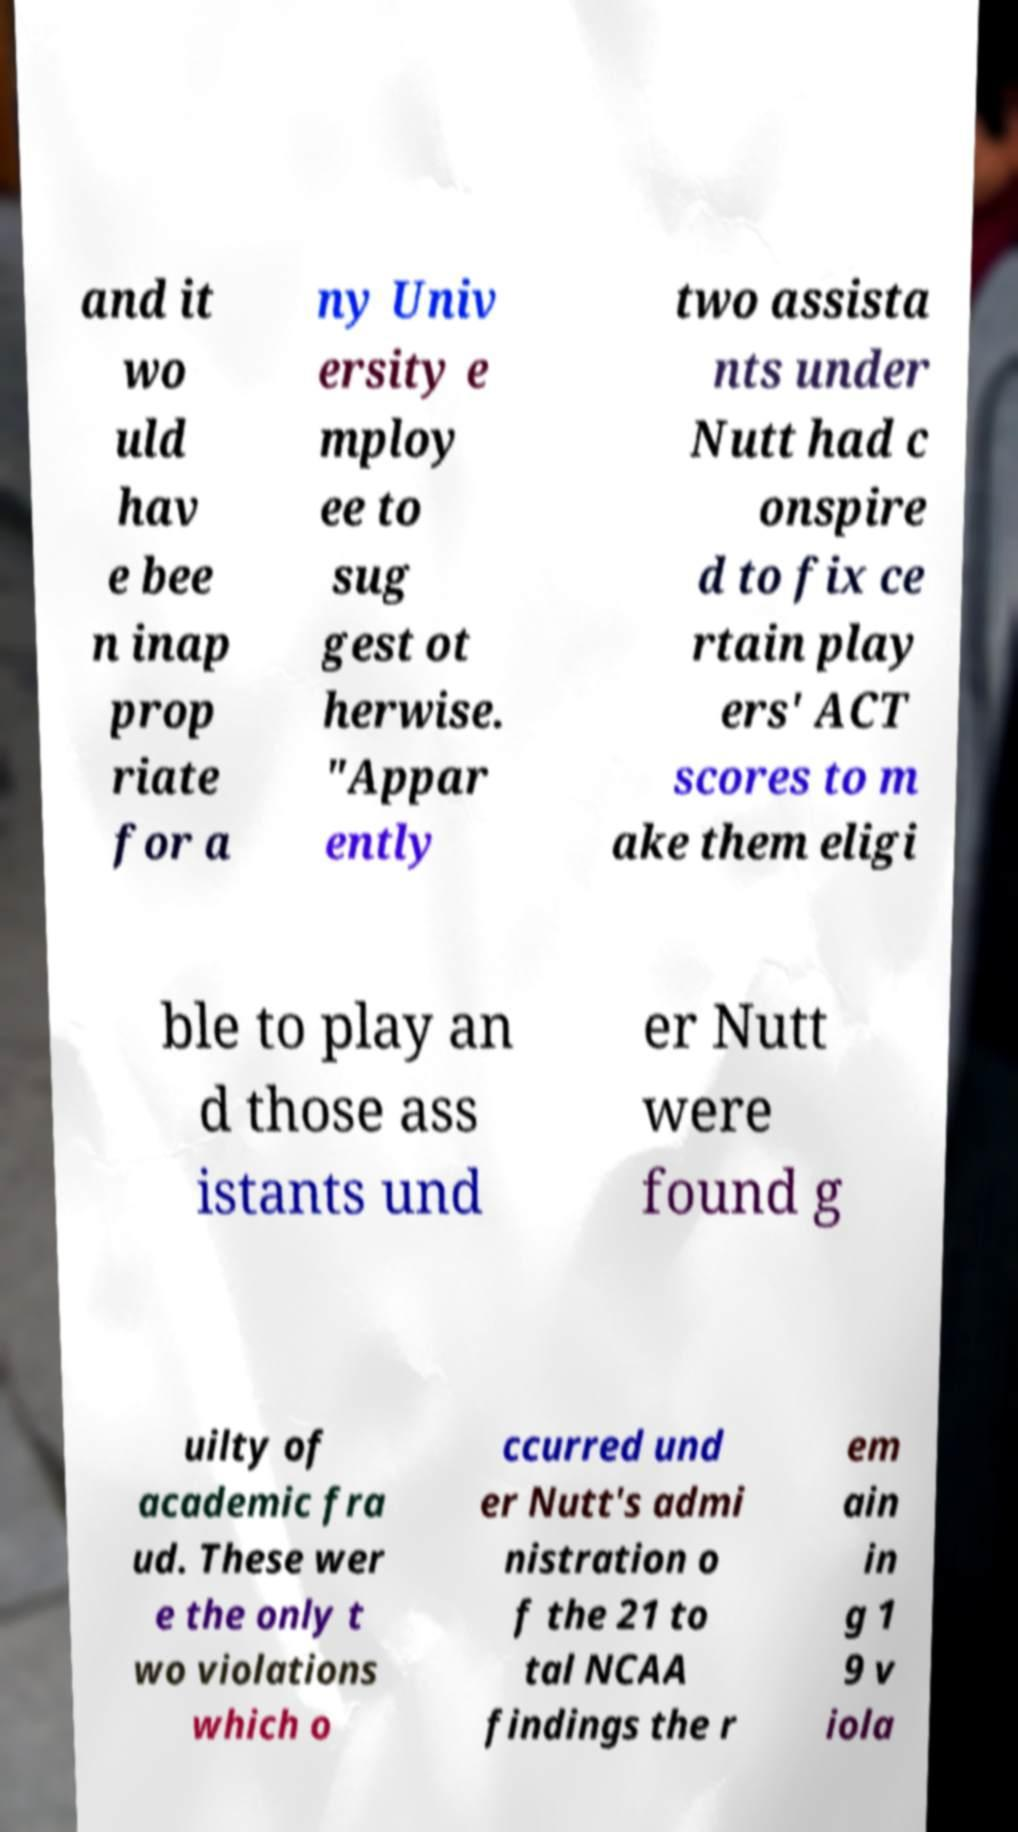Can you accurately transcribe the text from the provided image for me? and it wo uld hav e bee n inap prop riate for a ny Univ ersity e mploy ee to sug gest ot herwise. "Appar ently two assista nts under Nutt had c onspire d to fix ce rtain play ers' ACT scores to m ake them eligi ble to play an d those ass istants und er Nutt were found g uilty of academic fra ud. These wer e the only t wo violations which o ccurred und er Nutt's admi nistration o f the 21 to tal NCAA findings the r em ain in g 1 9 v iola 